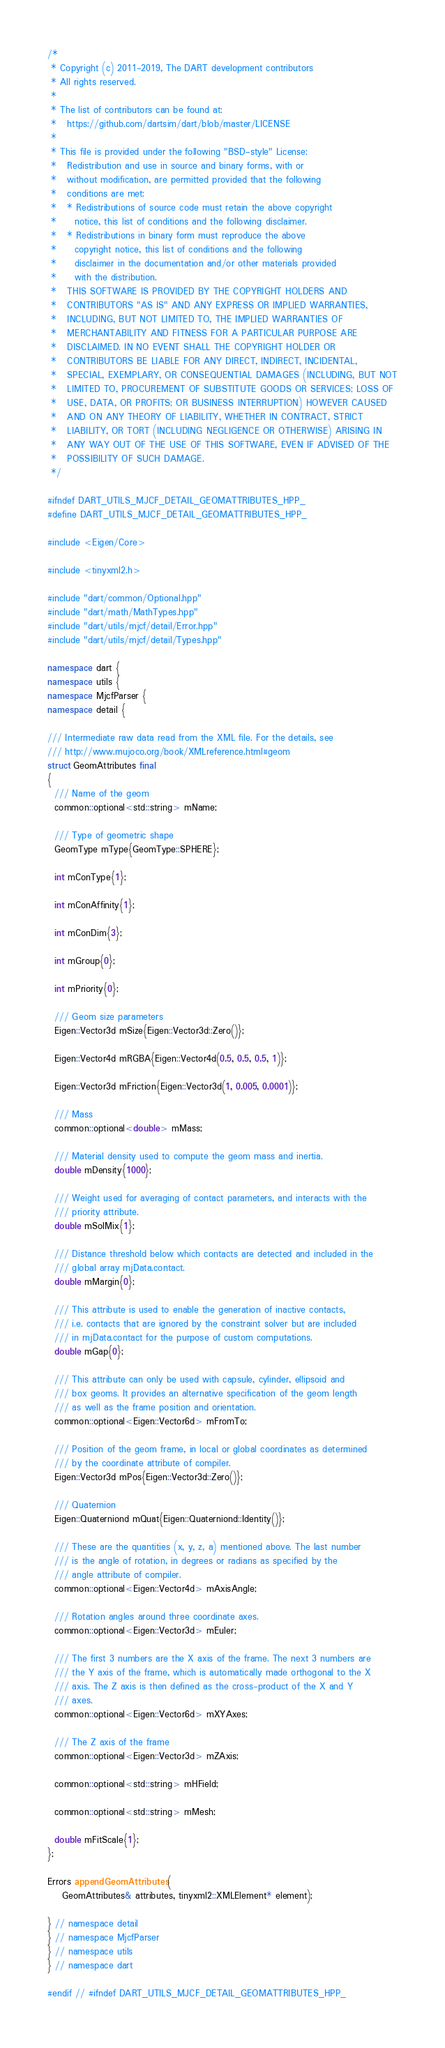<code> <loc_0><loc_0><loc_500><loc_500><_C++_>/*
 * Copyright (c) 2011-2019, The DART development contributors
 * All rights reserved.
 *
 * The list of contributors can be found at:
 *   https://github.com/dartsim/dart/blob/master/LICENSE
 *
 * This file is provided under the following "BSD-style" License:
 *   Redistribution and use in source and binary forms, with or
 *   without modification, are permitted provided that the following
 *   conditions are met:
 *   * Redistributions of source code must retain the above copyright
 *     notice, this list of conditions and the following disclaimer.
 *   * Redistributions in binary form must reproduce the above
 *     copyright notice, this list of conditions and the following
 *     disclaimer in the documentation and/or other materials provided
 *     with the distribution.
 *   THIS SOFTWARE IS PROVIDED BY THE COPYRIGHT HOLDERS AND
 *   CONTRIBUTORS "AS IS" AND ANY EXPRESS OR IMPLIED WARRANTIES,
 *   INCLUDING, BUT NOT LIMITED TO, THE IMPLIED WARRANTIES OF
 *   MERCHANTABILITY AND FITNESS FOR A PARTICULAR PURPOSE ARE
 *   DISCLAIMED. IN NO EVENT SHALL THE COPYRIGHT HOLDER OR
 *   CONTRIBUTORS BE LIABLE FOR ANY DIRECT, INDIRECT, INCIDENTAL,
 *   SPECIAL, EXEMPLARY, OR CONSEQUENTIAL DAMAGES (INCLUDING, BUT NOT
 *   LIMITED TO, PROCUREMENT OF SUBSTITUTE GOODS OR SERVICES; LOSS OF
 *   USE, DATA, OR PROFITS; OR BUSINESS INTERRUPTION) HOWEVER CAUSED
 *   AND ON ANY THEORY OF LIABILITY, WHETHER IN CONTRACT, STRICT
 *   LIABILITY, OR TORT (INCLUDING NEGLIGENCE OR OTHERWISE) ARISING IN
 *   ANY WAY OUT OF THE USE OF THIS SOFTWARE, EVEN IF ADVISED OF THE
 *   POSSIBILITY OF SUCH DAMAGE.
 */

#ifndef DART_UTILS_MJCF_DETAIL_GEOMATTRIBUTES_HPP_
#define DART_UTILS_MJCF_DETAIL_GEOMATTRIBUTES_HPP_

#include <Eigen/Core>

#include <tinyxml2.h>

#include "dart/common/Optional.hpp"
#include "dart/math/MathTypes.hpp"
#include "dart/utils/mjcf/detail/Error.hpp"
#include "dart/utils/mjcf/detail/Types.hpp"

namespace dart {
namespace utils {
namespace MjcfParser {
namespace detail {

/// Intermediate raw data read from the XML file. For the details, see
/// http://www.mujoco.org/book/XMLreference.html#geom
struct GeomAttributes final
{
  /// Name of the geom
  common::optional<std::string> mName;

  /// Type of geometric shape
  GeomType mType{GeomType::SPHERE};

  int mConType{1};

  int mConAffinity{1};

  int mConDim{3};

  int mGroup{0};

  int mPriority{0};

  /// Geom size parameters
  Eigen::Vector3d mSize{Eigen::Vector3d::Zero()};

  Eigen::Vector4d mRGBA{Eigen::Vector4d(0.5, 0.5, 0.5, 1)};

  Eigen::Vector3d mFriction{Eigen::Vector3d(1, 0.005, 0.0001)};

  /// Mass
  common::optional<double> mMass;

  /// Material density used to compute the geom mass and inertia.
  double mDensity{1000};

  /// Weight used for averaging of contact parameters, and interacts with the
  /// priority attribute.
  double mSolMix{1};

  /// Distance threshold below which contacts are detected and included in the
  /// global array mjData.contact.
  double mMargin{0};

  /// This attribute is used to enable the generation of inactive contacts,
  /// i.e. contacts that are ignored by the constraint solver but are included
  /// in mjData.contact for the purpose of custom computations.
  double mGap{0};

  /// This attribute can only be used with capsule, cylinder, ellipsoid and
  /// box geoms. It provides an alternative specification of the geom length
  /// as well as the frame position and orientation.
  common::optional<Eigen::Vector6d> mFromTo;

  /// Position of the geom frame, in local or global coordinates as determined
  /// by the coordinate attribute of compiler.
  Eigen::Vector3d mPos{Eigen::Vector3d::Zero()};

  /// Quaternion
  Eigen::Quaterniond mQuat{Eigen::Quaterniond::Identity()};

  /// These are the quantities (x, y, z, a) mentioned above. The last number
  /// is the angle of rotation, in degrees or radians as specified by the
  /// angle attribute of compiler.
  common::optional<Eigen::Vector4d> mAxisAngle;

  /// Rotation angles around three coordinate axes.
  common::optional<Eigen::Vector3d> mEuler;

  /// The first 3 numbers are the X axis of the frame. The next 3 numbers are
  /// the Y axis of the frame, which is automatically made orthogonal to the X
  /// axis. The Z axis is then defined as the cross-product of the X and Y
  /// axes.
  common::optional<Eigen::Vector6d> mXYAxes;

  /// The Z axis of the frame
  common::optional<Eigen::Vector3d> mZAxis;

  common::optional<std::string> mHField;

  common::optional<std::string> mMesh;

  double mFitScale{1};
};

Errors appendGeomAttributes(
    GeomAttributes& attributes, tinyxml2::XMLElement* element);

} // namespace detail
} // namespace MjcfParser
} // namespace utils
} // namespace dart

#endif // #ifndef DART_UTILS_MJCF_DETAIL_GEOMATTRIBUTES_HPP_
</code> 